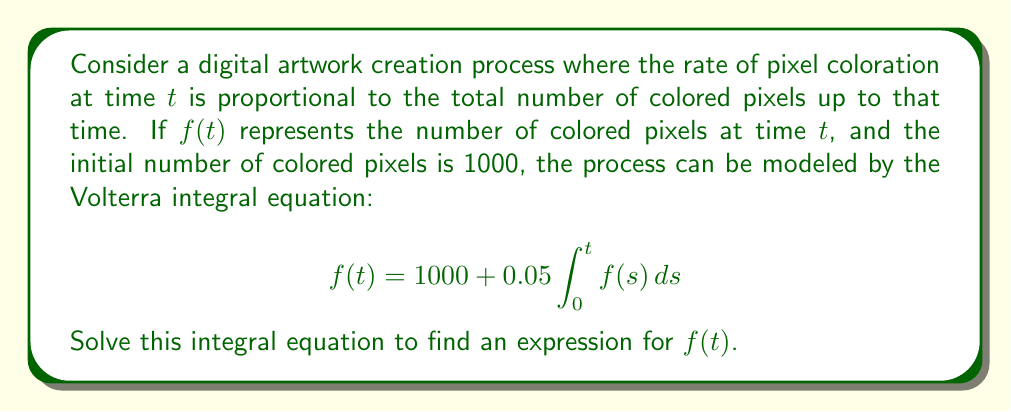Show me your answer to this math problem. Let's solve this Volterra integral equation step by step:

1) First, we differentiate both sides of the equation with respect to t:
   $$\frac{d}{dt}f(t) = \frac{d}{dt}(1000 + 0.05 \int_0^t f(s) ds)$$

2) Using the Fundamental Theorem of Calculus, we get:
   $$f'(t) = 0.05f(t)$$

3) This is now a simple first-order differential equation. We can solve it by separation of variables:
   $$\frac{df}{dt} = 0.05f$$
   $$\frac{df}{f} = 0.05dt$$

4) Integrating both sides:
   $$\int \frac{df}{f} = \int 0.05dt$$
   $$\ln|f| = 0.05t + C$$

5) Exponentiating both sides:
   $$f = Ae^{0.05t}$$
   where $A = e^C$ is a constant to be determined.

6) To find $A$, we use the initial condition. We know that $f(0) = 1000$:
   $$1000 = Ae^{0.05 \cdot 0} = A$$

7) Therefore, the final solution is:
   $$f(t) = 1000e^{0.05t}$$

This solution satisfies the initial condition and the differential equation derived from the integral equation.
Answer: $f(t) = 1000e^{0.05t}$ 